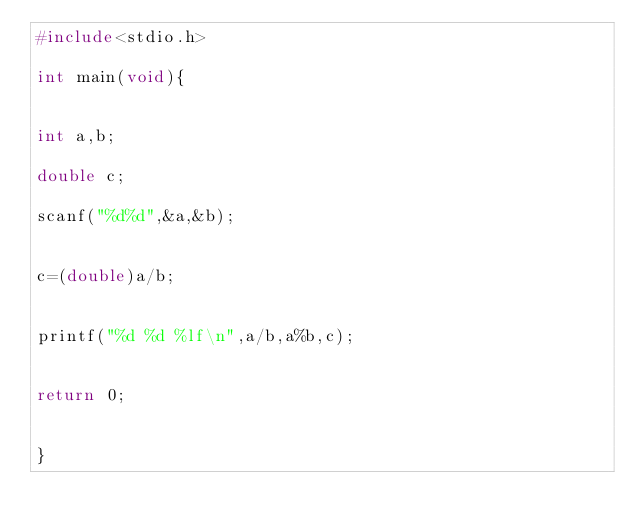<code> <loc_0><loc_0><loc_500><loc_500><_C_>#include<stdio.h>

int main(void){


int a,b;

double c;

scanf("%d%d",&a,&b);


c=(double)a/b;


printf("%d %d %lf\n",a/b,a%b,c);


return 0;


}</code> 